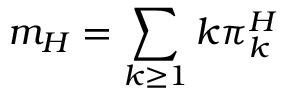Convert formula to latex. <formula><loc_0><loc_0><loc_500><loc_500>m _ { H } = \sum _ { k \geq 1 } k \pi _ { k } ^ { H }</formula> 